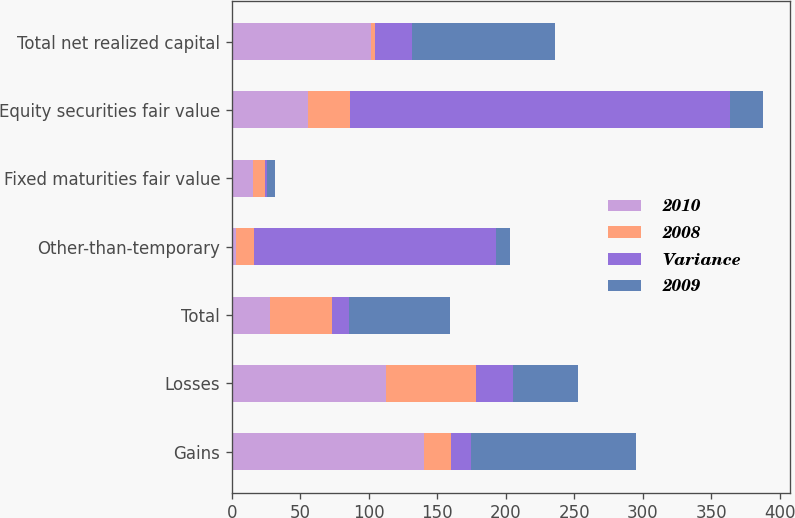Convert chart to OTSL. <chart><loc_0><loc_0><loc_500><loc_500><stacked_bar_chart><ecel><fcel>Gains<fcel>Losses<fcel>Total<fcel>Other-than-temporary<fcel>Fixed maturities fair value<fcel>Equity securities fair value<fcel>Total net realized capital<nl><fcel>2010<fcel>140.2<fcel>112.8<fcel>27.5<fcel>3<fcel>15.1<fcel>55.3<fcel>101.9<nl><fcel>2008<fcel>19.7<fcel>65.4<fcel>45.7<fcel>13.2<fcel>9.3<fcel>30.9<fcel>2.3<nl><fcel>Variance<fcel>14.5<fcel>27.2<fcel>12.6<fcel>176.5<fcel>1.5<fcel>277.5<fcel>27.5<nl><fcel>2009<fcel>120.5<fcel>47.4<fcel>73.2<fcel>10.2<fcel>5.8<fcel>24.4<fcel>104.2<nl></chart> 